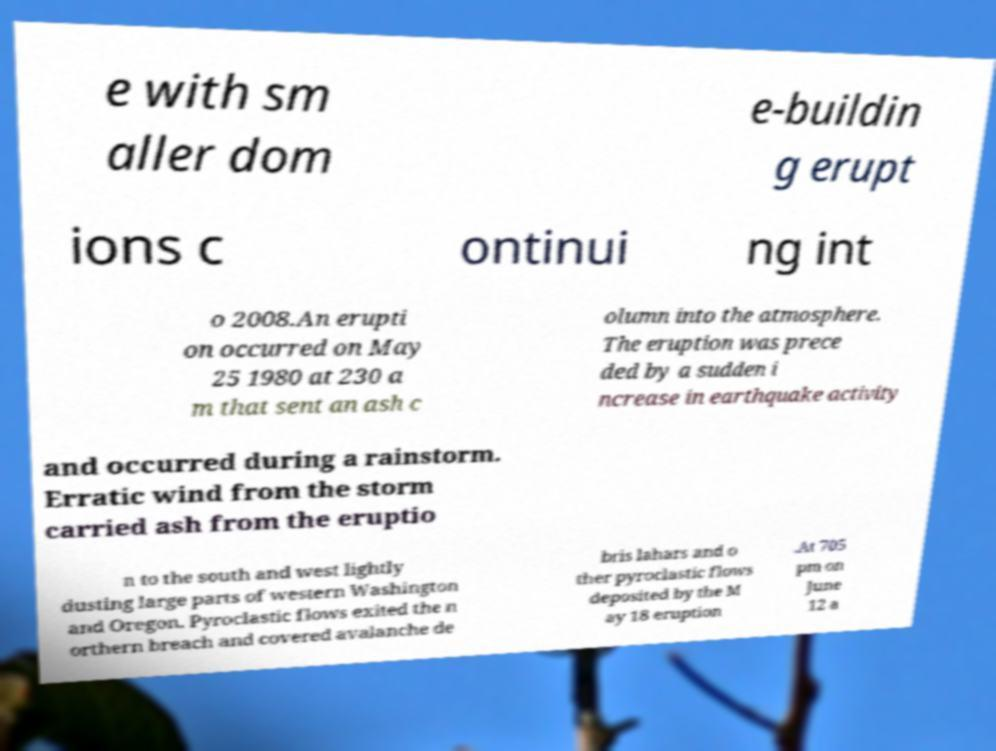Can you accurately transcribe the text from the provided image for me? e with sm aller dom e-buildin g erupt ions c ontinui ng int o 2008.An erupti on occurred on May 25 1980 at 230 a m that sent an ash c olumn into the atmosphere. The eruption was prece ded by a sudden i ncrease in earthquake activity and occurred during a rainstorm. Erratic wind from the storm carried ash from the eruptio n to the south and west lightly dusting large parts of western Washington and Oregon. Pyroclastic flows exited the n orthern breach and covered avalanche de bris lahars and o ther pyroclastic flows deposited by the M ay 18 eruption .At 705 pm on June 12 a 